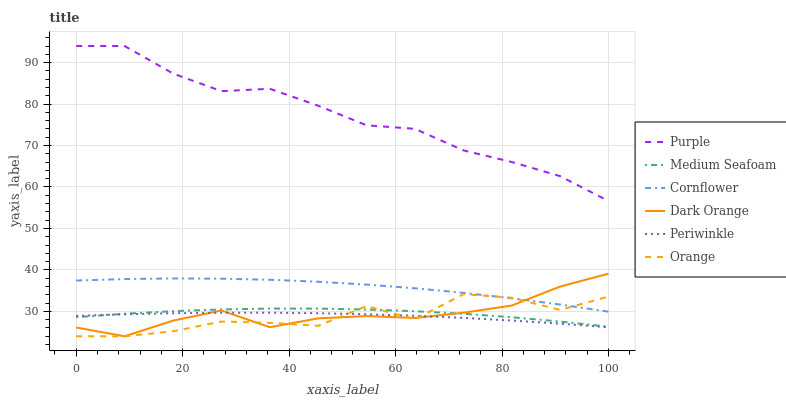Does Orange have the minimum area under the curve?
Answer yes or no. Yes. Does Purple have the maximum area under the curve?
Answer yes or no. Yes. Does Dark Orange have the minimum area under the curve?
Answer yes or no. No. Does Dark Orange have the maximum area under the curve?
Answer yes or no. No. Is Periwinkle the smoothest?
Answer yes or no. Yes. Is Orange the roughest?
Answer yes or no. Yes. Is Dark Orange the smoothest?
Answer yes or no. No. Is Dark Orange the roughest?
Answer yes or no. No. Does Dark Orange have the lowest value?
Answer yes or no. Yes. Does Purple have the lowest value?
Answer yes or no. No. Does Purple have the highest value?
Answer yes or no. Yes. Does Dark Orange have the highest value?
Answer yes or no. No. Is Periwinkle less than Purple?
Answer yes or no. Yes. Is Purple greater than Orange?
Answer yes or no. Yes. Does Orange intersect Dark Orange?
Answer yes or no. Yes. Is Orange less than Dark Orange?
Answer yes or no. No. Is Orange greater than Dark Orange?
Answer yes or no. No. Does Periwinkle intersect Purple?
Answer yes or no. No. 